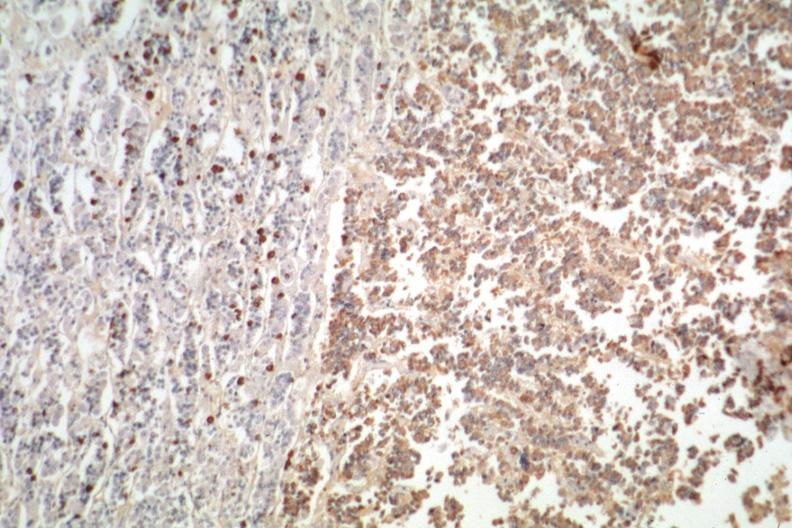where is this part in the figure?
Answer the question using a single word or phrase. Endocrine system 